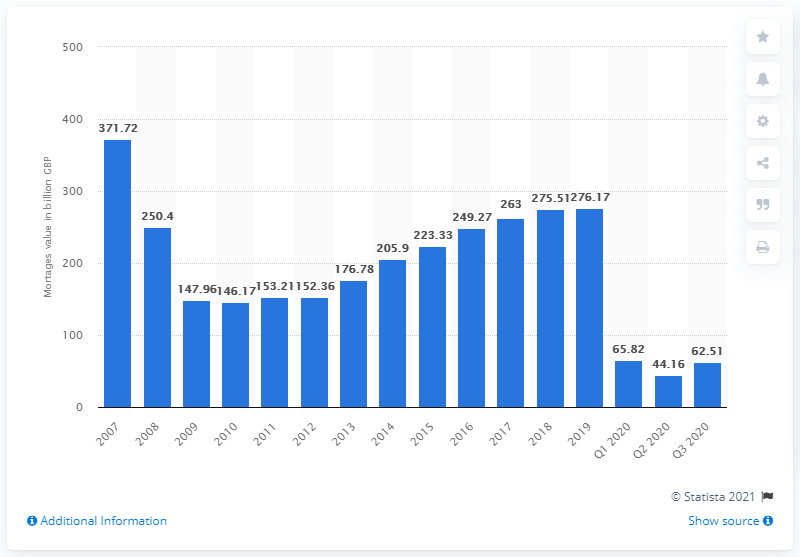Specify some key components in this picture. The total value of gross mortgage lending in 2019 was 276.17. In 2007, the total value of gross mortgage lending was 371.72. In 2010, the smallest amount of gross mortgage lending in the UK was 146.17. 